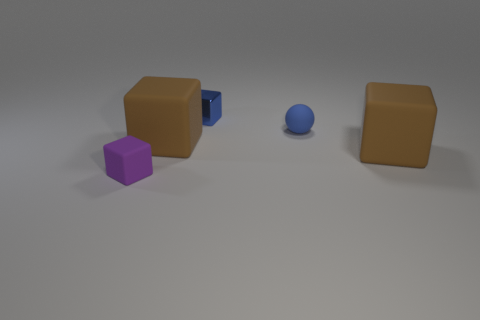Add 5 large blocks. How many objects exist? 10 Subtract all balls. How many objects are left? 4 Add 4 rubber balls. How many rubber balls are left? 5 Add 4 rubber spheres. How many rubber spheres exist? 5 Subtract 0 gray blocks. How many objects are left? 5 Subtract all blue blocks. Subtract all small rubber cubes. How many objects are left? 3 